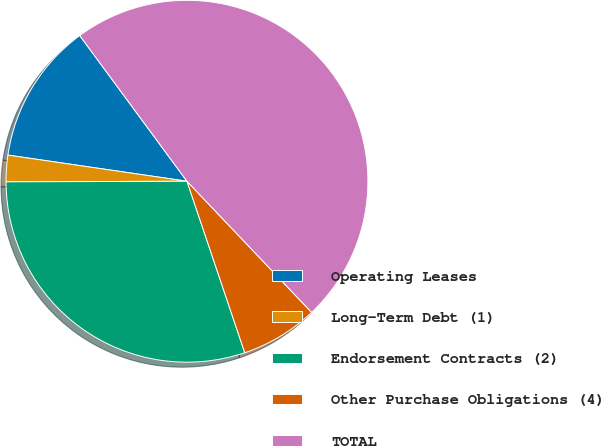Convert chart. <chart><loc_0><loc_0><loc_500><loc_500><pie_chart><fcel>Operating Leases<fcel>Long-Term Debt (1)<fcel>Endorsement Contracts (2)<fcel>Other Purchase Obligations (4)<fcel>TOTAL<nl><fcel>12.59%<fcel>2.36%<fcel>30.12%<fcel>6.92%<fcel>48.0%<nl></chart> 